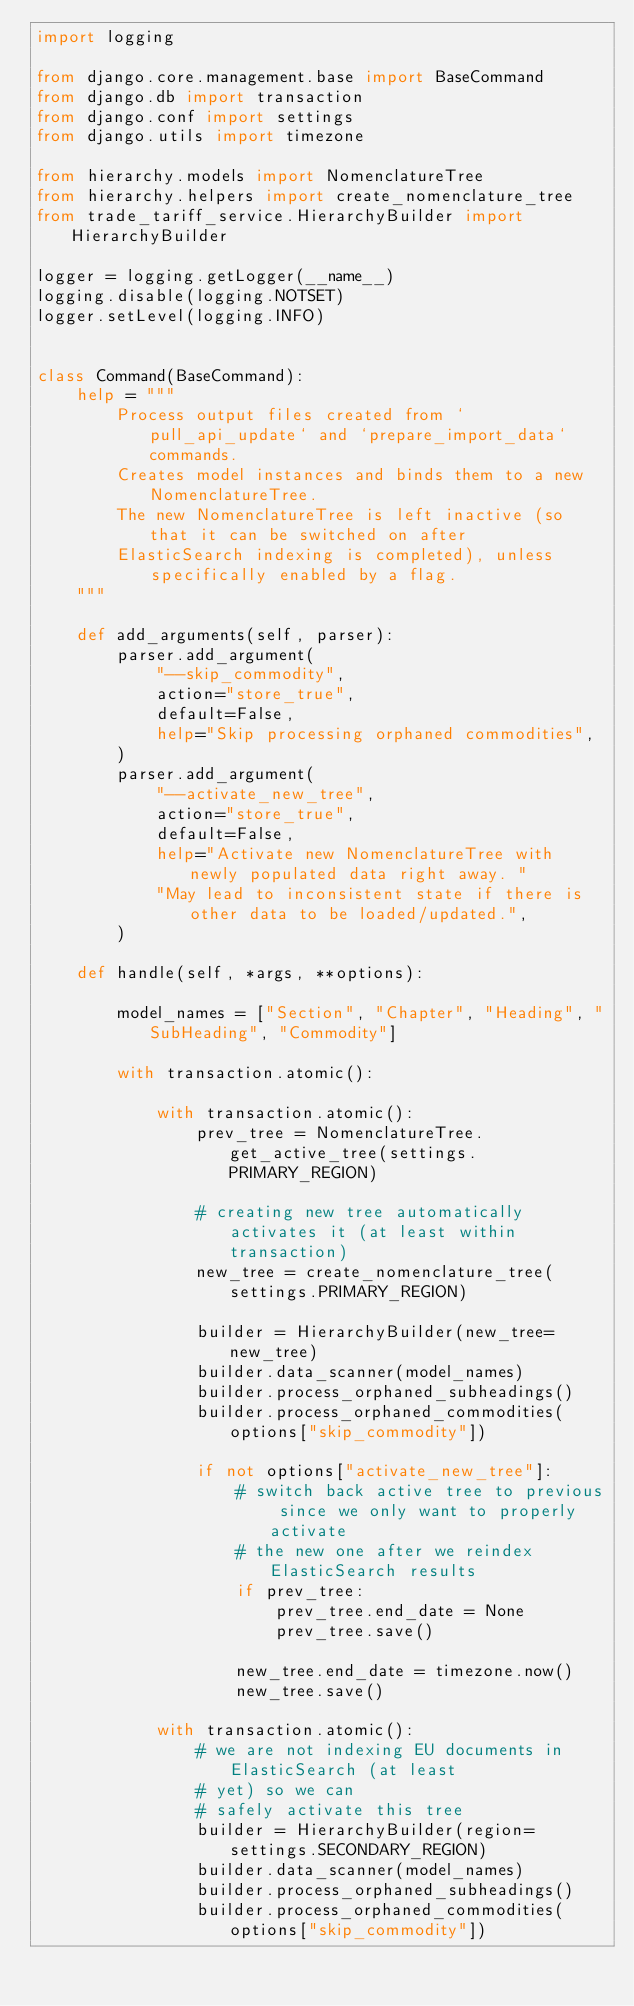<code> <loc_0><loc_0><loc_500><loc_500><_Python_>import logging

from django.core.management.base import BaseCommand
from django.db import transaction
from django.conf import settings
from django.utils import timezone

from hierarchy.models import NomenclatureTree
from hierarchy.helpers import create_nomenclature_tree
from trade_tariff_service.HierarchyBuilder import HierarchyBuilder

logger = logging.getLogger(__name__)
logging.disable(logging.NOTSET)
logger.setLevel(logging.INFO)


class Command(BaseCommand):
    help = """
        Process output files created from `pull_api_update` and `prepare_import_data` commands.
        Creates model instances and binds them to a new NomenclatureTree.
        The new NomenclatureTree is left inactive (so that it can be switched on after
        ElasticSearch indexing is completed), unless specifically enabled by a flag.
    """

    def add_arguments(self, parser):
        parser.add_argument(
            "--skip_commodity",
            action="store_true",
            default=False,
            help="Skip processing orphaned commodities",
        )
        parser.add_argument(
            "--activate_new_tree",
            action="store_true",
            default=False,
            help="Activate new NomenclatureTree with newly populated data right away. "
            "May lead to inconsistent state if there is other data to be loaded/updated.",
        )

    def handle(self, *args, **options):

        model_names = ["Section", "Chapter", "Heading", "SubHeading", "Commodity"]

        with transaction.atomic():

            with transaction.atomic():
                prev_tree = NomenclatureTree.get_active_tree(settings.PRIMARY_REGION)

                # creating new tree automatically activates it (at least within transaction)
                new_tree = create_nomenclature_tree(settings.PRIMARY_REGION)

                builder = HierarchyBuilder(new_tree=new_tree)
                builder.data_scanner(model_names)
                builder.process_orphaned_subheadings()
                builder.process_orphaned_commodities(options["skip_commodity"])

                if not options["activate_new_tree"]:
                    # switch back active tree to previous since we only want to properly activate
                    # the new one after we reindex ElasticSearch results
                    if prev_tree:
                        prev_tree.end_date = None
                        prev_tree.save()

                    new_tree.end_date = timezone.now()
                    new_tree.save()

            with transaction.atomic():
                # we are not indexing EU documents in ElasticSearch (at least
                # yet) so we can
                # safely activate this tree
                builder = HierarchyBuilder(region=settings.SECONDARY_REGION)
                builder.data_scanner(model_names)
                builder.process_orphaned_subheadings()
                builder.process_orphaned_commodities(options["skip_commodity"])
</code> 